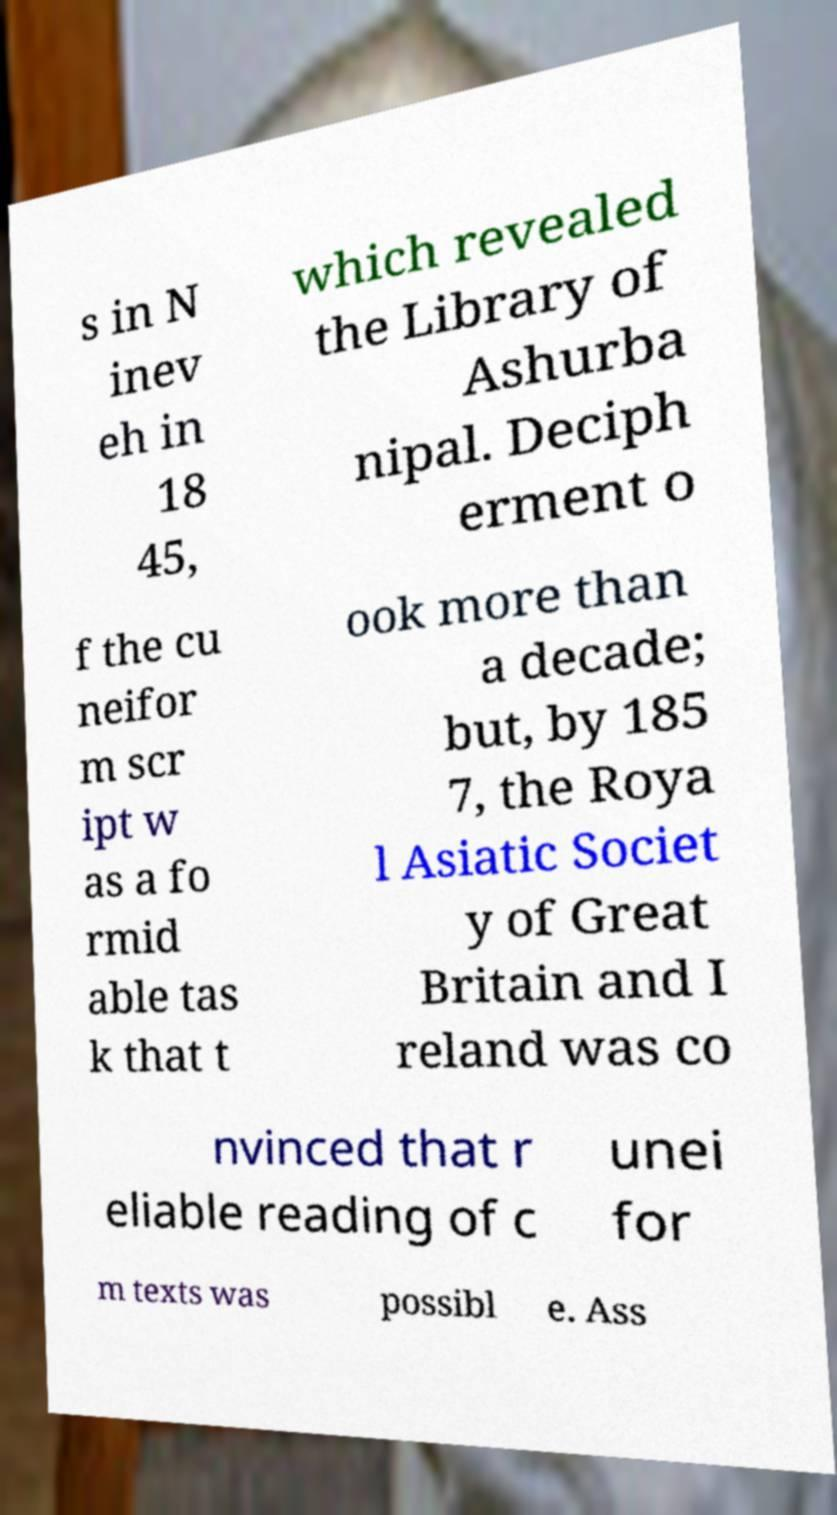I need the written content from this picture converted into text. Can you do that? s in N inev eh in 18 45, which revealed the Library of Ashurba nipal. Deciph erment o f the cu neifor m scr ipt w as a fo rmid able tas k that t ook more than a decade; but, by 185 7, the Roya l Asiatic Societ y of Great Britain and I reland was co nvinced that r eliable reading of c unei for m texts was possibl e. Ass 